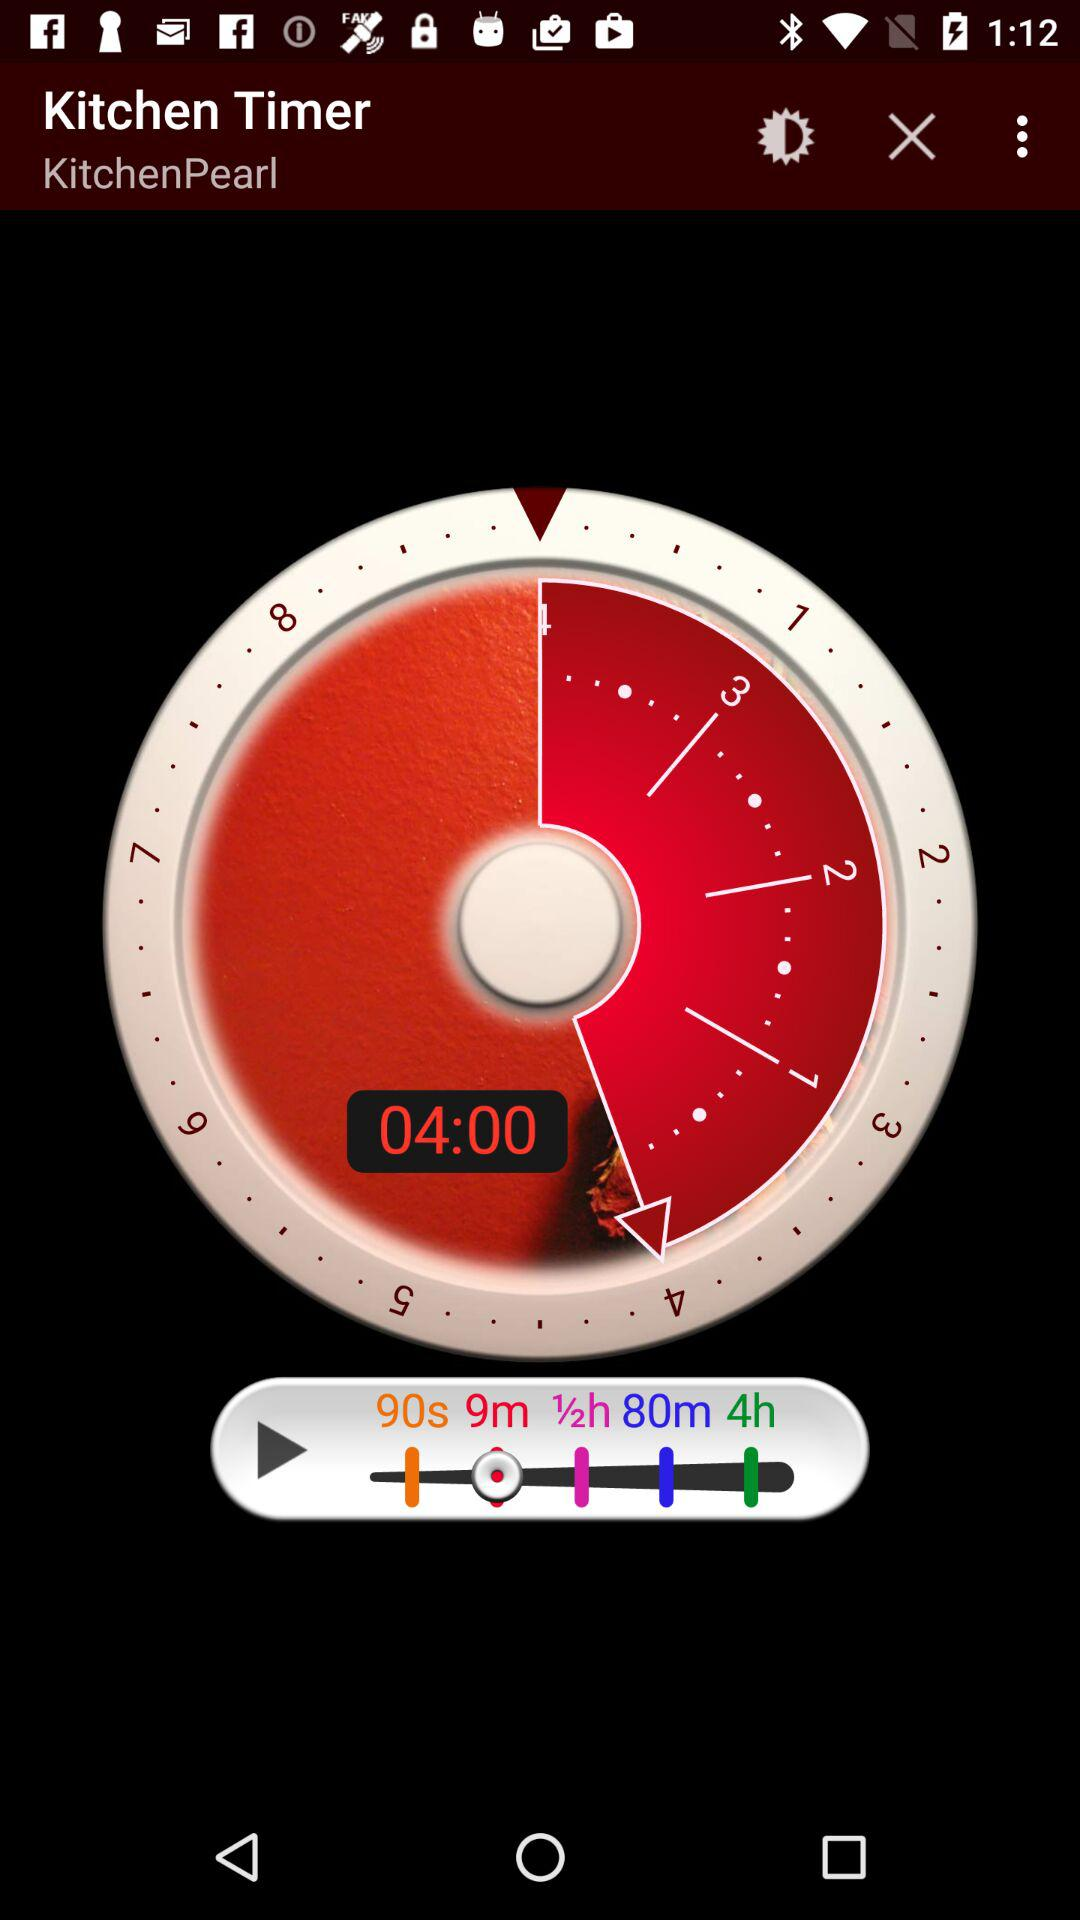What time duration is displayed on the screen? The time duration displayed on the screen is 4 minutes. 